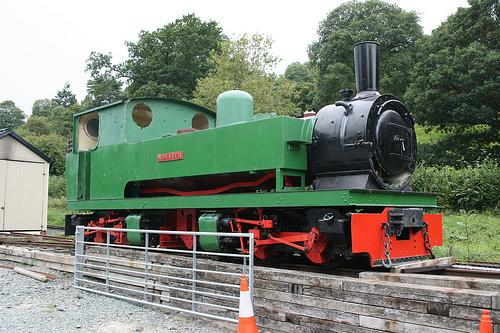Describe the objects seen near the train tracks. There are wooden railroad timbers, traffic cones, metal fencing, and a white and black shack near the train tracks. Provide a brief description of the main elements in the image. An orange and green steam engine, a line of trees in the background, orange and white traffic cones, a gray railing, a white and black shack, and a metal fence. Mention the dominant color and object seen in the image. The dominant color is orange, and the main object is a steam engine. Provide a detailed description of the steam engine's appearance. The steam engine is both green and orange, with warning cones near it, chains on the front, round windows, and an orange train scoop. What is unique about the setting of the train? The train is situated near a white and black shack, a small brick wall, and is surrounded by wooden railroad timbers and traffic cones. What background features can be seen behind the train engine? Behind the train engine, there are trees on a hill and a gray sky overhead. Give a description of the train's front appearance. The front of the train features an orange plate with giant hooks, chains, a black steam engine, and round windows in the locomotive. Mention some of the smaller details present in the image. There is a label on the train, a chain on the train, a brown wooden plank, and a circular hole in a train. Describe the environment surrounding the train in the image. The train is surrounded by trees, a white and black shack, traffic cones, a metal fence, and wooden railroad timbers. List the various objects found around the train engine. Objects around the train engine include a conductor's station, traffic cones, a metal fence, a white and black shack, and wooden railroad timbers. 